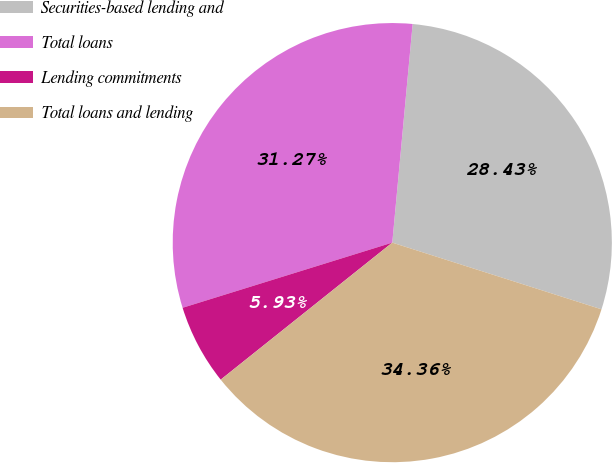Convert chart. <chart><loc_0><loc_0><loc_500><loc_500><pie_chart><fcel>Securities-based lending and<fcel>Total loans<fcel>Lending commitments<fcel>Total loans and lending<nl><fcel>28.43%<fcel>31.27%<fcel>5.93%<fcel>34.36%<nl></chart> 